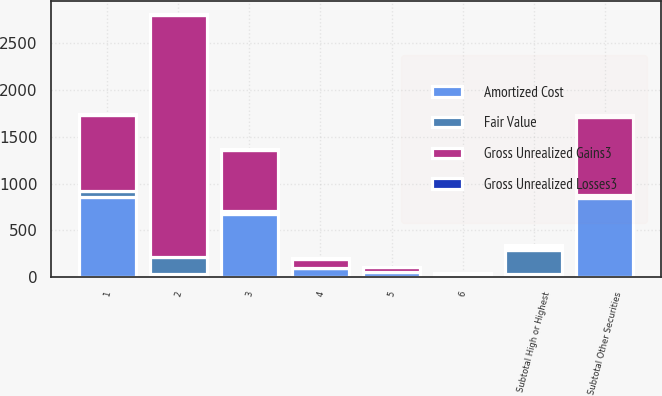Convert chart to OTSL. <chart><loc_0><loc_0><loc_500><loc_500><stacked_bar_chart><ecel><fcel>1<fcel>2<fcel>Subtotal High or Highest<fcel>3<fcel>4<fcel>5<fcel>6<fcel>Subtotal Other Securities<nl><fcel>Gross Unrealized Gains3<fcel>805<fcel>2584<fcel>33<fcel>656<fcel>98<fcel>54<fcel>23<fcel>831<nl><fcel>Fair Value<fcel>66<fcel>187<fcel>253<fcel>27<fcel>4<fcel>1<fcel>1<fcel>33<nl><fcel>Gross Unrealized Losses3<fcel>11<fcel>10<fcel>21<fcel>6<fcel>5<fcel>4<fcel>6<fcel>21<nl><fcel>Amortized Cost<fcel>860<fcel>33<fcel>33<fcel>677<fcel>97<fcel>51<fcel>18<fcel>843<nl></chart> 